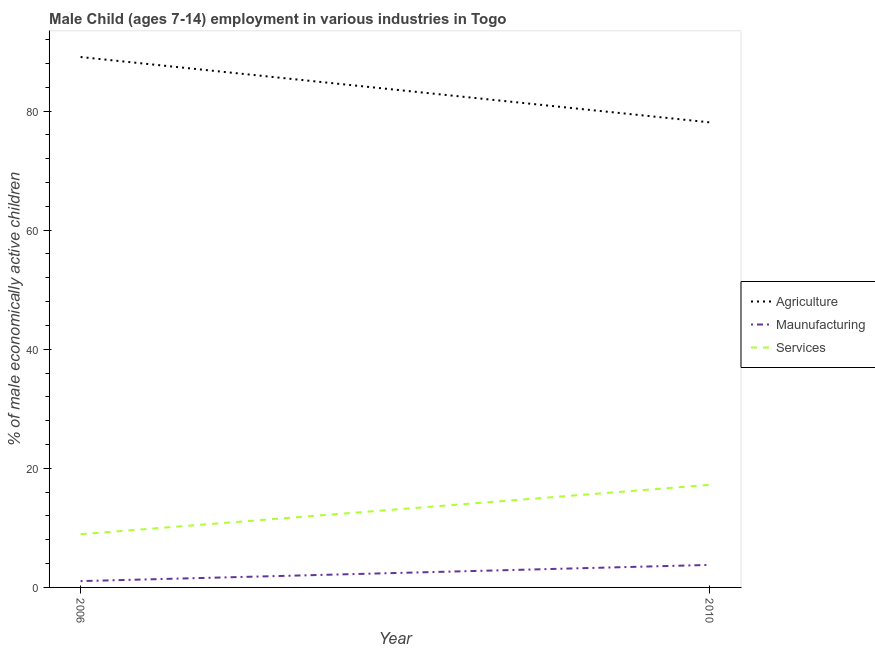Is the number of lines equal to the number of legend labels?
Offer a very short reply. Yes. What is the percentage of economically active children in services in 2006?
Keep it short and to the point. 8.94. Across all years, what is the maximum percentage of economically active children in services?
Offer a terse response. 17.23. Across all years, what is the minimum percentage of economically active children in services?
Offer a terse response. 8.94. In which year was the percentage of economically active children in services maximum?
Give a very brief answer. 2010. In which year was the percentage of economically active children in manufacturing minimum?
Make the answer very short. 2006. What is the total percentage of economically active children in agriculture in the graph?
Make the answer very short. 167.19. What is the difference between the percentage of economically active children in agriculture in 2006 and that in 2010?
Make the answer very short. 10.97. What is the difference between the percentage of economically active children in services in 2010 and the percentage of economically active children in agriculture in 2006?
Your answer should be compact. -71.85. What is the average percentage of economically active children in manufacturing per year?
Offer a very short reply. 2.42. In the year 2010, what is the difference between the percentage of economically active children in agriculture and percentage of economically active children in services?
Provide a succinct answer. 60.88. In how many years, is the percentage of economically active children in agriculture greater than 8 %?
Your answer should be compact. 2. What is the ratio of the percentage of economically active children in services in 2006 to that in 2010?
Your answer should be very brief. 0.52. Is the percentage of economically active children in agriculture in 2006 less than that in 2010?
Ensure brevity in your answer.  No. In how many years, is the percentage of economically active children in agriculture greater than the average percentage of economically active children in agriculture taken over all years?
Offer a terse response. 1. Is it the case that in every year, the sum of the percentage of economically active children in agriculture and percentage of economically active children in manufacturing is greater than the percentage of economically active children in services?
Offer a very short reply. Yes. Is the percentage of economically active children in services strictly greater than the percentage of economically active children in manufacturing over the years?
Offer a terse response. Yes. How many lines are there?
Keep it short and to the point. 3. How many years are there in the graph?
Your answer should be very brief. 2. What is the difference between two consecutive major ticks on the Y-axis?
Offer a terse response. 20. Are the values on the major ticks of Y-axis written in scientific E-notation?
Offer a terse response. No. Does the graph contain any zero values?
Keep it short and to the point. No. Does the graph contain grids?
Your response must be concise. No. What is the title of the graph?
Make the answer very short. Male Child (ages 7-14) employment in various industries in Togo. What is the label or title of the X-axis?
Provide a short and direct response. Year. What is the label or title of the Y-axis?
Your answer should be very brief. % of male economically active children. What is the % of male economically active children of Agriculture in 2006?
Provide a succinct answer. 89.08. What is the % of male economically active children in Maunufacturing in 2006?
Offer a terse response. 1.06. What is the % of male economically active children of Services in 2006?
Your answer should be compact. 8.94. What is the % of male economically active children in Agriculture in 2010?
Provide a succinct answer. 78.11. What is the % of male economically active children in Maunufacturing in 2010?
Keep it short and to the point. 3.78. What is the % of male economically active children of Services in 2010?
Your answer should be compact. 17.23. Across all years, what is the maximum % of male economically active children in Agriculture?
Give a very brief answer. 89.08. Across all years, what is the maximum % of male economically active children in Maunufacturing?
Give a very brief answer. 3.78. Across all years, what is the maximum % of male economically active children in Services?
Provide a short and direct response. 17.23. Across all years, what is the minimum % of male economically active children of Agriculture?
Give a very brief answer. 78.11. Across all years, what is the minimum % of male economically active children of Maunufacturing?
Provide a short and direct response. 1.06. Across all years, what is the minimum % of male economically active children in Services?
Keep it short and to the point. 8.94. What is the total % of male economically active children in Agriculture in the graph?
Provide a succinct answer. 167.19. What is the total % of male economically active children of Maunufacturing in the graph?
Keep it short and to the point. 4.84. What is the total % of male economically active children of Services in the graph?
Give a very brief answer. 26.17. What is the difference between the % of male economically active children of Agriculture in 2006 and that in 2010?
Keep it short and to the point. 10.97. What is the difference between the % of male economically active children of Maunufacturing in 2006 and that in 2010?
Make the answer very short. -2.72. What is the difference between the % of male economically active children in Services in 2006 and that in 2010?
Give a very brief answer. -8.29. What is the difference between the % of male economically active children in Agriculture in 2006 and the % of male economically active children in Maunufacturing in 2010?
Ensure brevity in your answer.  85.3. What is the difference between the % of male economically active children of Agriculture in 2006 and the % of male economically active children of Services in 2010?
Make the answer very short. 71.85. What is the difference between the % of male economically active children in Maunufacturing in 2006 and the % of male economically active children in Services in 2010?
Your response must be concise. -16.17. What is the average % of male economically active children of Agriculture per year?
Your answer should be compact. 83.59. What is the average % of male economically active children of Maunufacturing per year?
Keep it short and to the point. 2.42. What is the average % of male economically active children in Services per year?
Make the answer very short. 13.09. In the year 2006, what is the difference between the % of male economically active children in Agriculture and % of male economically active children in Maunufacturing?
Keep it short and to the point. 88.02. In the year 2006, what is the difference between the % of male economically active children in Agriculture and % of male economically active children in Services?
Offer a terse response. 80.14. In the year 2006, what is the difference between the % of male economically active children of Maunufacturing and % of male economically active children of Services?
Your answer should be compact. -7.88. In the year 2010, what is the difference between the % of male economically active children of Agriculture and % of male economically active children of Maunufacturing?
Your answer should be very brief. 74.33. In the year 2010, what is the difference between the % of male economically active children in Agriculture and % of male economically active children in Services?
Provide a short and direct response. 60.88. In the year 2010, what is the difference between the % of male economically active children of Maunufacturing and % of male economically active children of Services?
Offer a very short reply. -13.45. What is the ratio of the % of male economically active children of Agriculture in 2006 to that in 2010?
Provide a short and direct response. 1.14. What is the ratio of the % of male economically active children of Maunufacturing in 2006 to that in 2010?
Provide a short and direct response. 0.28. What is the ratio of the % of male economically active children in Services in 2006 to that in 2010?
Keep it short and to the point. 0.52. What is the difference between the highest and the second highest % of male economically active children in Agriculture?
Provide a short and direct response. 10.97. What is the difference between the highest and the second highest % of male economically active children in Maunufacturing?
Keep it short and to the point. 2.72. What is the difference between the highest and the second highest % of male economically active children in Services?
Offer a terse response. 8.29. What is the difference between the highest and the lowest % of male economically active children of Agriculture?
Provide a short and direct response. 10.97. What is the difference between the highest and the lowest % of male economically active children of Maunufacturing?
Provide a short and direct response. 2.72. What is the difference between the highest and the lowest % of male economically active children of Services?
Make the answer very short. 8.29. 